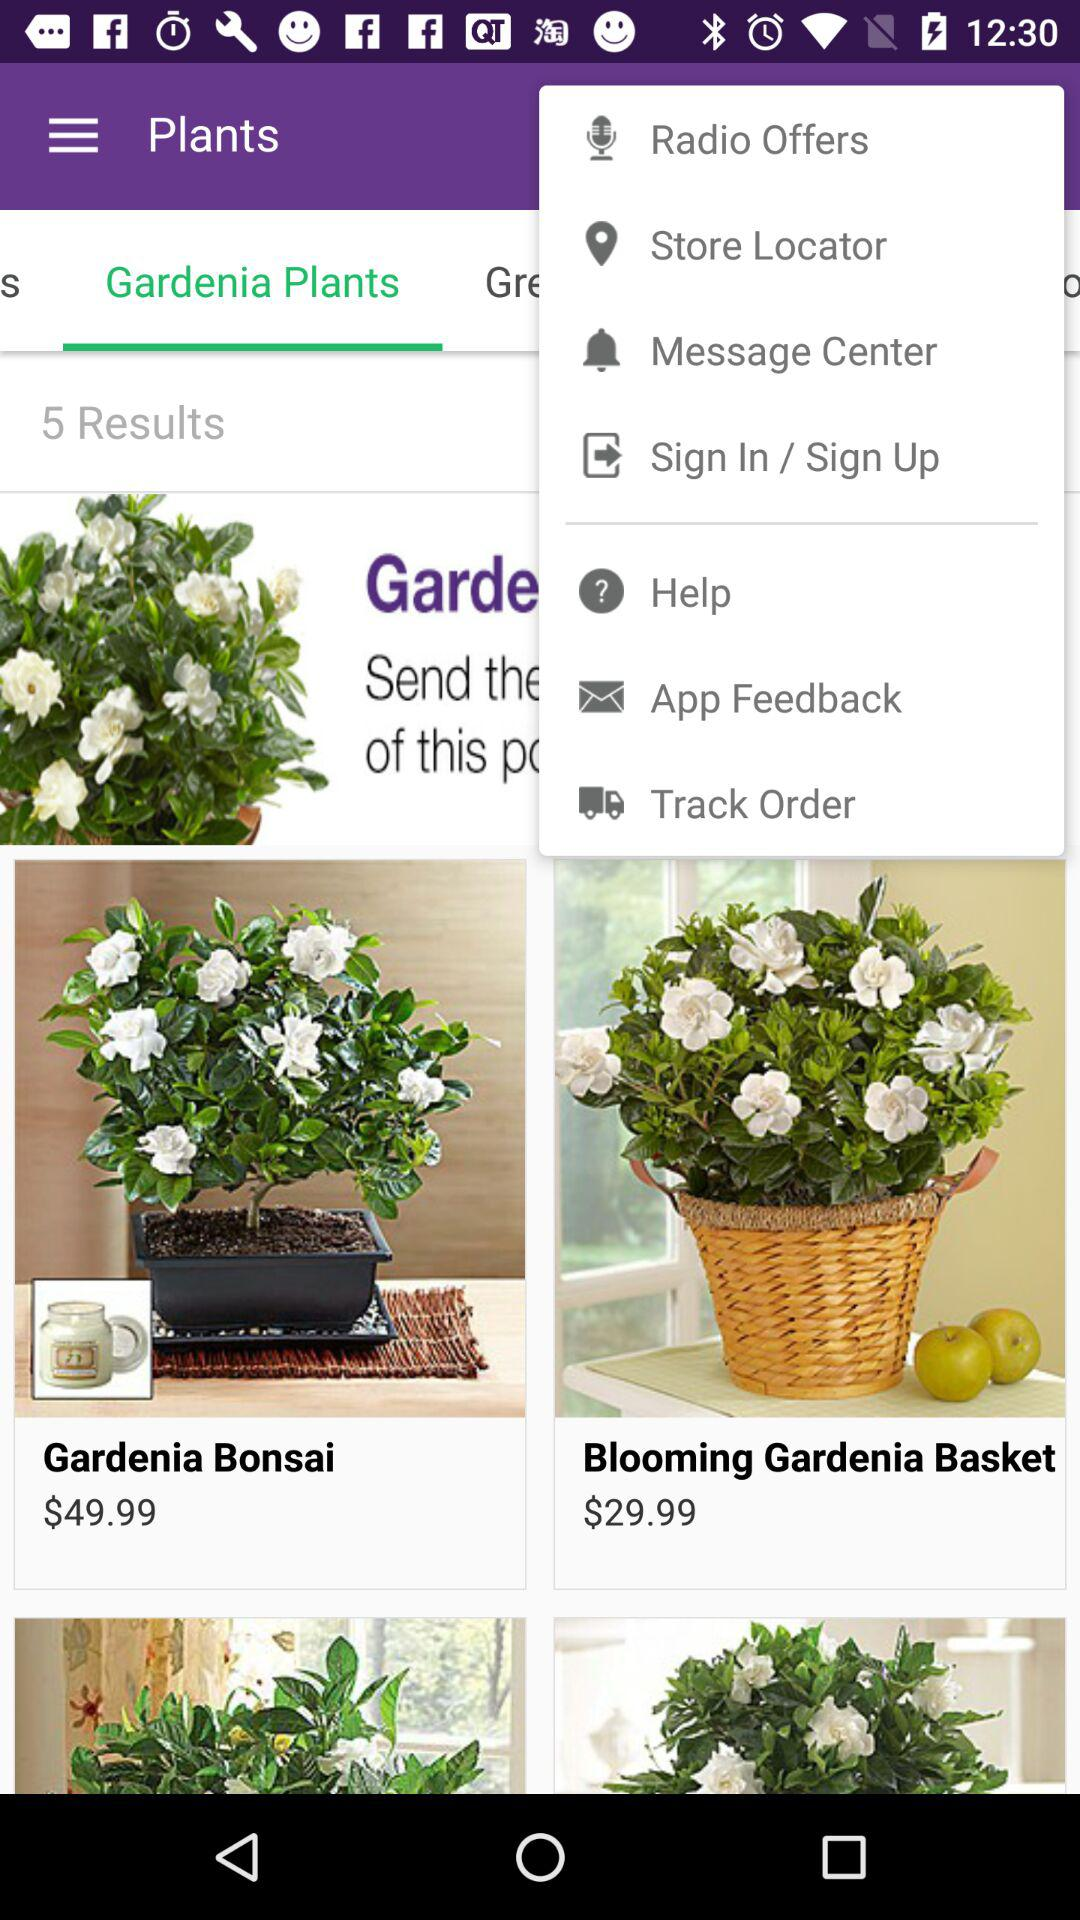How many results are shown on the screen? The results shown on the screen are 5. 